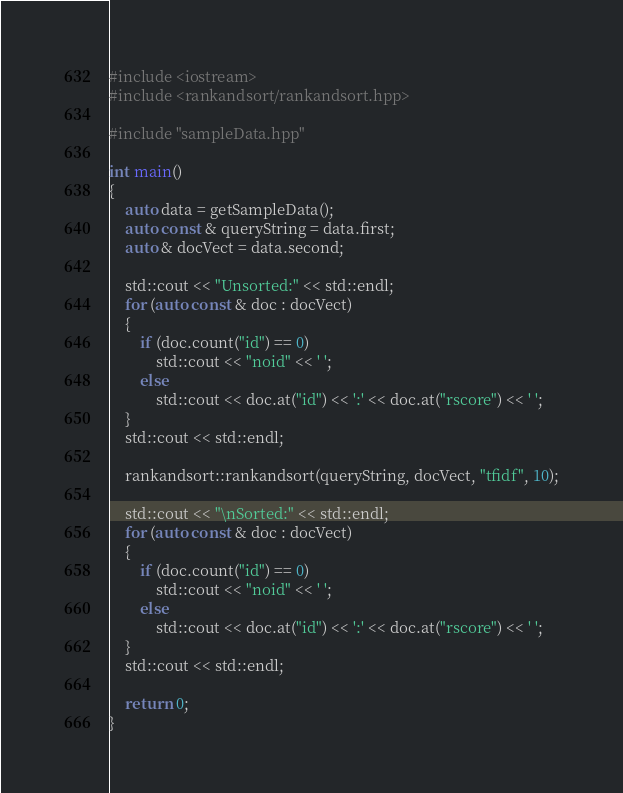Convert code to text. <code><loc_0><loc_0><loc_500><loc_500><_C++_>#include <iostream>
#include <rankandsort/rankandsort.hpp>

#include "sampleData.hpp"

int main()
{
    auto data = getSampleData();
    auto const & queryString = data.first;
    auto & docVect = data.second;

    std::cout << "Unsorted:" << std::endl;
    for (auto const & doc : docVect)
    {
        if (doc.count("id") == 0)
            std::cout << "noid" << ' ';
        else
            std::cout << doc.at("id") << ':' << doc.at("rscore") << ' ';
    }
    std::cout << std::endl;

    rankandsort::rankandsort(queryString, docVect, "tfidf", 10);

    std::cout << "\nSorted:" << std::endl;
    for (auto const & doc : docVect)
    {
        if (doc.count("id") == 0)
            std::cout << "noid" << ' ';
        else
            std::cout << doc.at("id") << ':' << doc.at("rscore") << ' ';
    }
    std::cout << std::endl;

    return 0;
}
</code> 